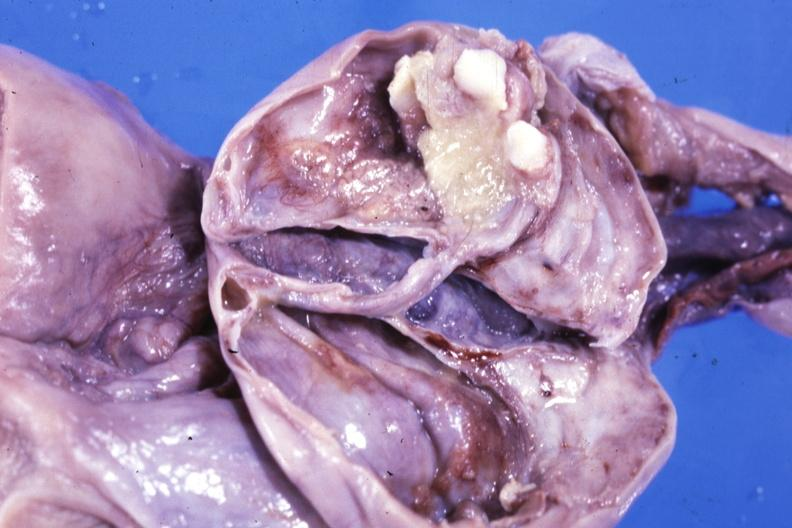what does this image show?
Answer the question using a single word or phrase. Fixed tissue opened ovarian cyst with two or three teeth 